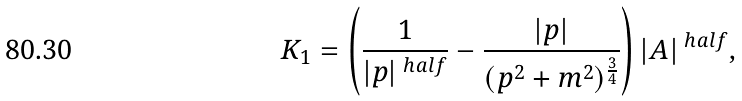<formula> <loc_0><loc_0><loc_500><loc_500>K _ { 1 } = \left ( \frac { 1 } { | p | ^ { \ h a l f } } - \frac { | p | } { ( p ^ { 2 } + m ^ { 2 } ) ^ { \frac { 3 } { 4 } } } \right ) | A | ^ { \ h a l f } ,</formula> 